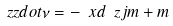Convert formula to latex. <formula><loc_0><loc_0><loc_500><loc_500>\ z z d o t { \nu } = - \ x d \ z j m + m</formula> 